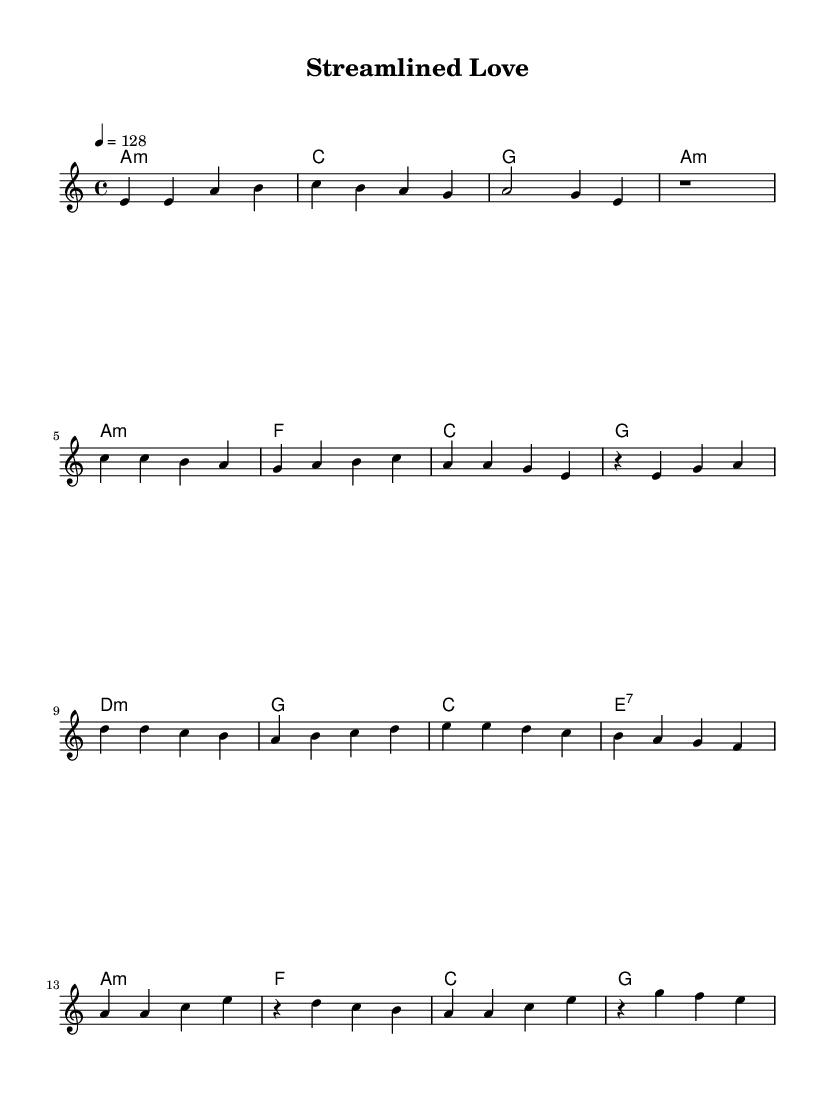What is the key signature of this music? The key signature is one flat, indicating A minor, which shares the same key signature as C major but starts on A.
Answer: A minor What is the time signature of this piece? The time signature is four beats per measure, as indicated by the 4/4 marking at the beginning of the score.
Answer: 4/4 What is the tempo marking for this music? The tempo marking is quarter note equals 128 beats per minute, meaning there are 128 beats per minute, which indicates a moderately fast pace.
Answer: 128 How many sections are there in this composition? The composition is structured into four distinct sections: Intro, Verse, Pre-Chorus, and Chorus. Identifying headers or changes in music notation indicates these sections.
Answer: Four What type of harmonic progression is used in the Chorus? In the Chorus, the harmonic progression follows a classic pop structure which alternates between A minor, F major, C major, and G major chords. This is common in K-Pop music for creating upbeat melodies.
Answer: A minor, F, C, G What is the first note of the melody in the Verse section? The first note of the melody in the Verse section is C, as indicated by the first note in the melody line under the verse.
Answer: C Which musical component indicates the use of modern minimalism in this piece? The use of repetitive, simple melodic lines and straightforward harmonic progressions, which characterize minimalist design principles, emphasizes clarity and streamlined aesthetics typical in modern K-Pop tunes.
Answer: Simple melodic lines 